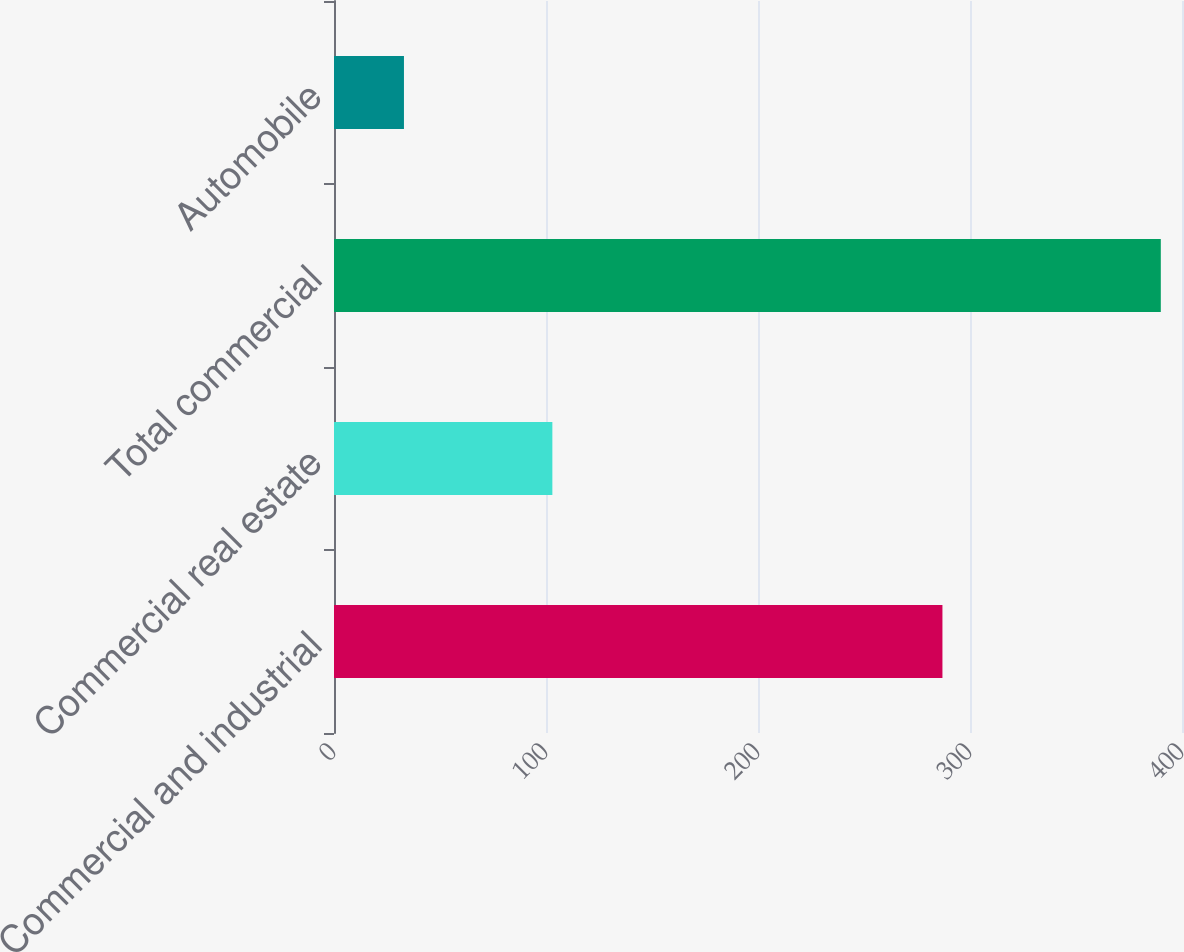<chart> <loc_0><loc_0><loc_500><loc_500><bar_chart><fcel>Commercial and industrial<fcel>Commercial real estate<fcel>Total commercial<fcel>Automobile<nl><fcel>287<fcel>103<fcel>390<fcel>33<nl></chart> 